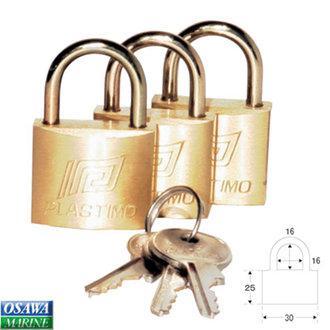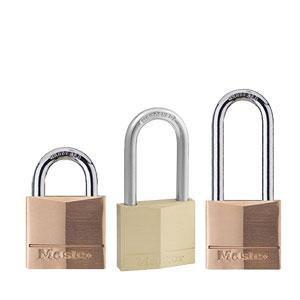The first image is the image on the left, the second image is the image on the right. Given the left and right images, does the statement "A ring holding three keys is next to a padlock in one image." hold true? Answer yes or no. Yes. The first image is the image on the left, the second image is the image on the right. For the images shown, is this caption "There is a single set of keys with the locks." true? Answer yes or no. Yes. 